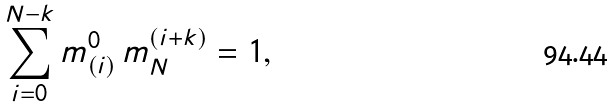Convert formula to latex. <formula><loc_0><loc_0><loc_500><loc_500>\sum _ { i = 0 } ^ { N - k } m ^ { 0 } _ { ( i ) } \, m ^ { ( i + k ) } _ { N } = 1 ,</formula> 